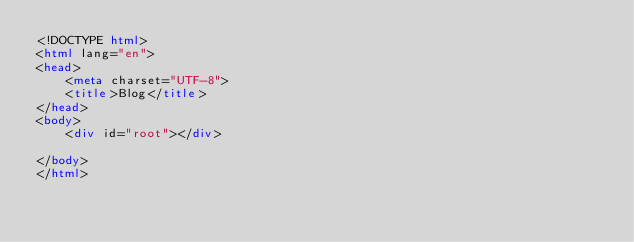<code> <loc_0><loc_0><loc_500><loc_500><_HTML_><!DOCTYPE html>
<html lang="en">
<head>
    <meta charset="UTF-8">
    <title>Blog</title>
</head>
<body>
    <div id="root"></div>

</body>
</html></code> 